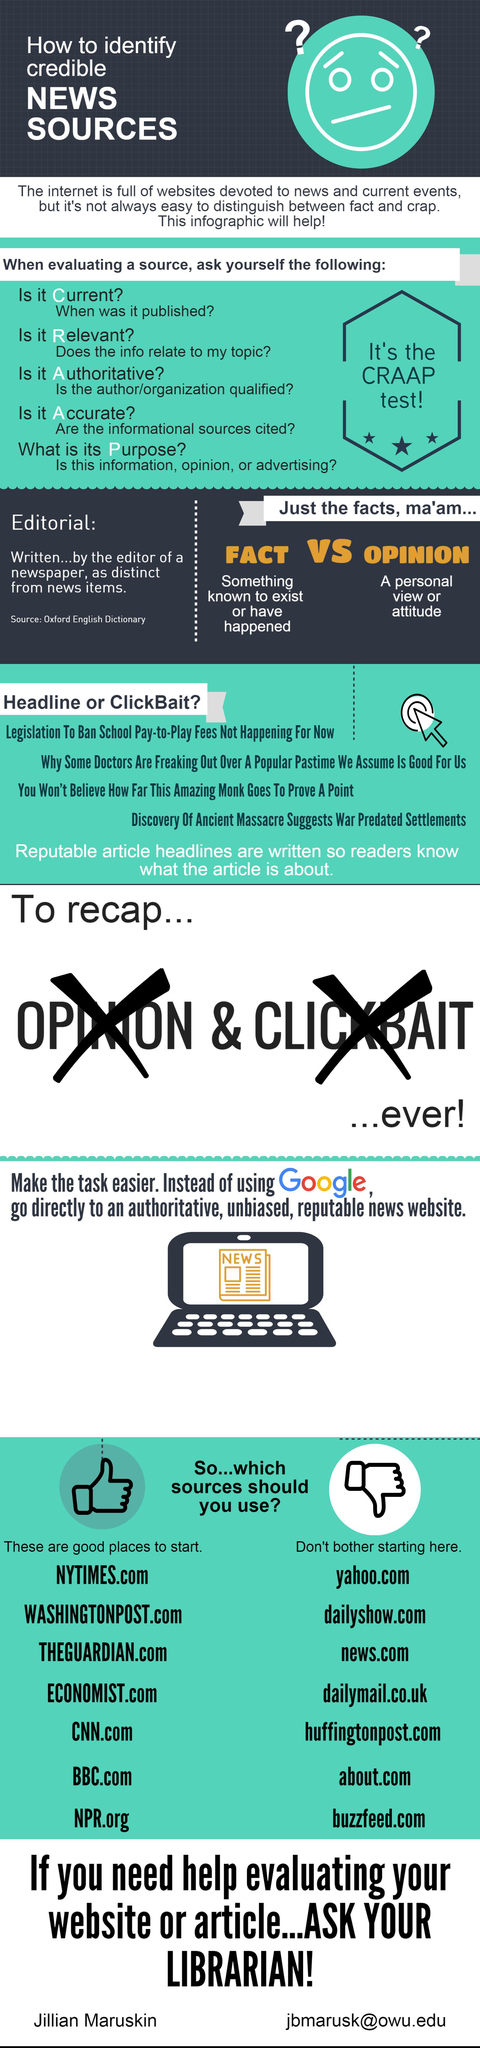Identify some key points in this picture. I would like to start with seven good sites. The word 'News' is written on the laptop. 